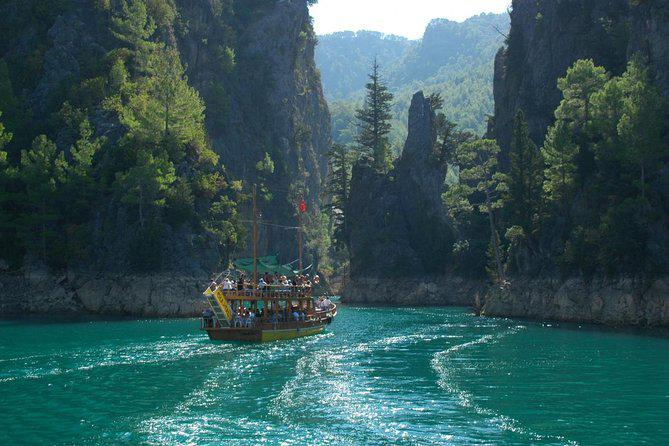Can you tell me about the vegetation in the area? Certainly! The area is rich with dense greenery, indicating a healthy, thriving ecosystem. The trees and plants clinging to the steep cliffs appear to be predominantly evergreen, suggesting this region may have a climate conducive to such foliage year-round. Is this place accessible for hikers or just by boat? While the image primarily shows access by water, the surrounding landscape with its dense forest suggests there could be hiking trails available. These trails may offer a variety of viewpoints and opportunities to explore the local flora and fauna. 